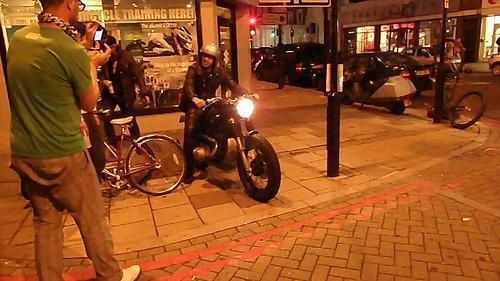How many people are taking pictures?
Give a very brief answer. 1. How many lights does the motorcycle have?
Give a very brief answer. 1. 